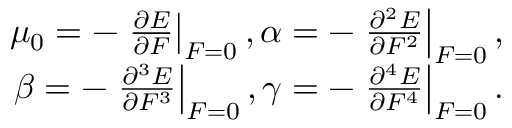Convert formula to latex. <formula><loc_0><loc_0><loc_500><loc_500>\begin{array} { r } { \mu _ { 0 } = - \frac { \partial E } { \partial F } \right | _ { F = 0 } , \alpha = - \frac { \partial ^ { 2 } E } { \partial F ^ { 2 } } \right | _ { F = 0 } , } \\ { \beta = - \frac { \partial ^ { 3 } E } { \partial F ^ { 3 } } \right | _ { F = 0 } , \gamma = - \frac { \partial ^ { 4 } E } { \partial F ^ { 4 } } \right | _ { F = 0 } . } \end{array}</formula> 